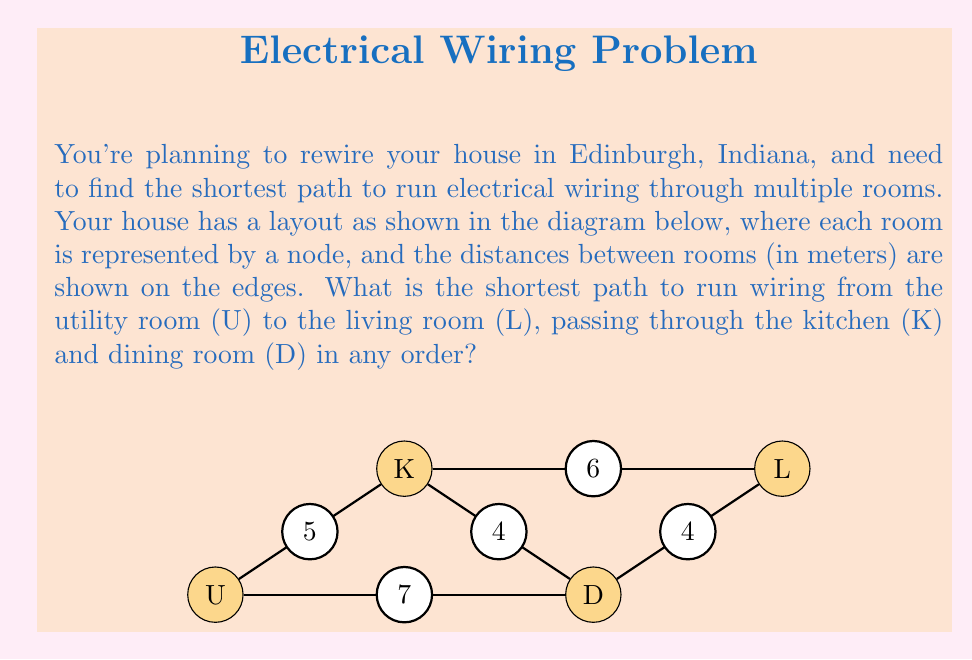Teach me how to tackle this problem. To solve this problem, we need to find the shortest path that includes all required nodes (U, K, D, L) in the given graph. We can use Dijkstra's algorithm or simply compare all possible paths:

1. Possible paths:
   a) U → K → D → L
   b) U → K → L → D → L
   c) U → D → K → L
   d) U → D → L → K → L

2. Calculate the length of each path:
   a) U → K → D → L = 5 + 4 + 4 = 13 meters
   b) U → K → L → D → L = 5 + 6 + 4 + 4 = 19 meters
   c) U → D → K → L = 7 + 4 + 6 = 17 meters
   d) U → D → L → K → L = 7 + 4 + 6 + 6 = 23 meters

3. Compare the lengths:
   The shortest path is (a) U → K → D → L, with a total length of 13 meters.

This path satisfies all requirements: it starts at the utility room (U), passes through the kitchen (K) and dining room (D), and ends at the living room (L).
Answer: U → K → D → L, 13 meters 